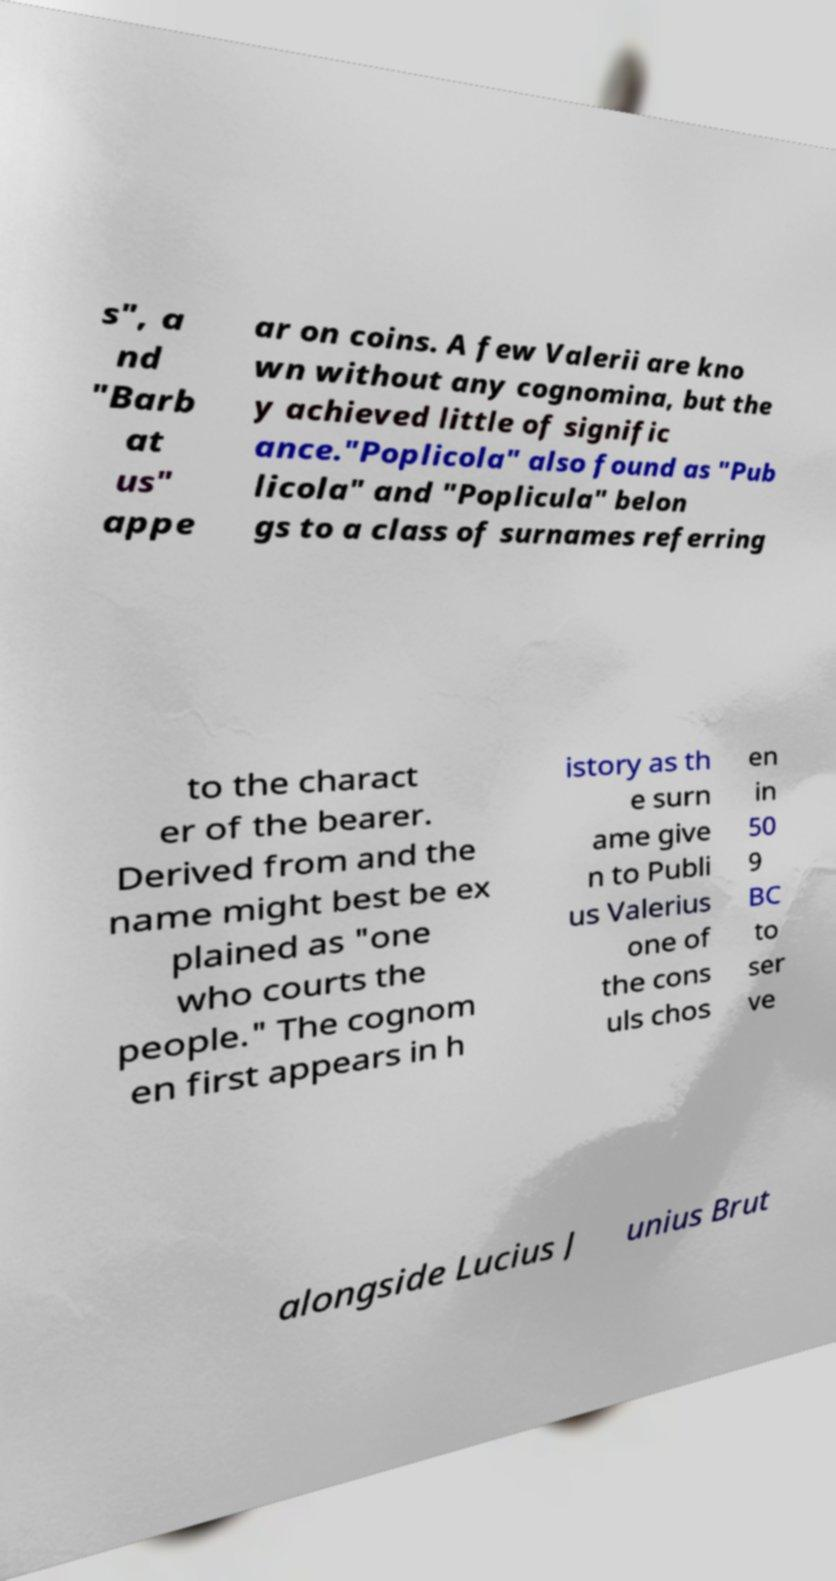Could you assist in decoding the text presented in this image and type it out clearly? s", a nd "Barb at us" appe ar on coins. A few Valerii are kno wn without any cognomina, but the y achieved little of signific ance."Poplicola" also found as "Pub licola" and "Poplicula" belon gs to a class of surnames referring to the charact er of the bearer. Derived from and the name might best be ex plained as "one who courts the people." The cognom en first appears in h istory as th e surn ame give n to Publi us Valerius one of the cons uls chos en in 50 9 BC to ser ve alongside Lucius J unius Brut 